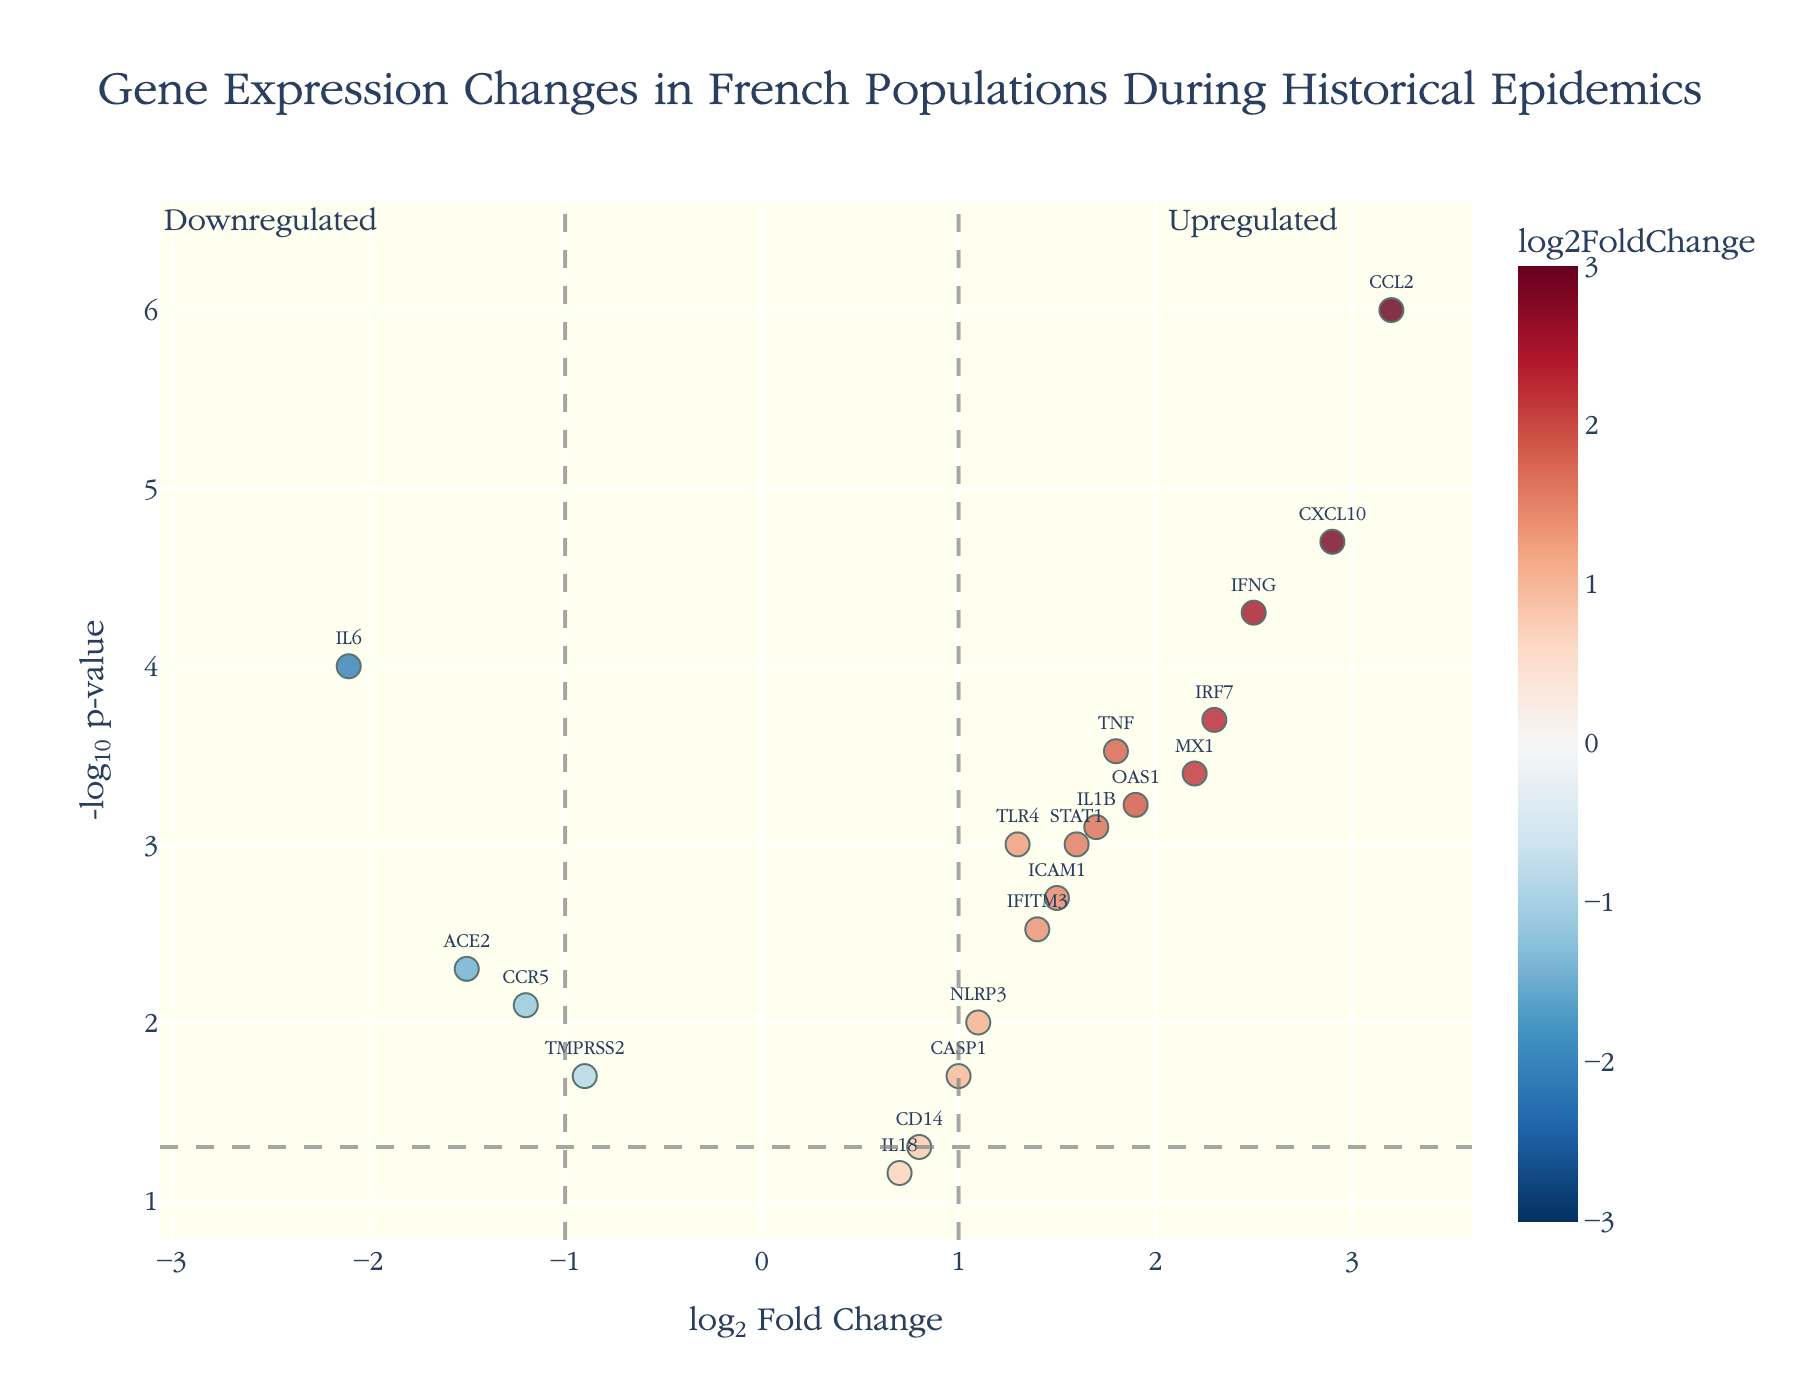what is the title of the plot? The title of the plot is located at the top center of the figure and provides a brief description of what the plot represents. By looking at the top of the figure, we can see that the title reads "Gene Expression Changes in French Populations During Historical Epidemics."
Answer: Gene Expression Changes in French Populations During Historical Epidemics Which gene has the highest -log10(p-value)? To determine the gene with the highest -log10(p-value), we look at the y-axis, which represents -log10(p-value), and identify the data point that reaches the highest position along this axis.
Answer: CCL2 Which genes are downregulated and have a p-value below 0.05? First, identify the genes with negative log2FoldChange values. Then check that their y-values, representing -log10(p-value), are above the horizontal threshold line (since higher -log10(p-value) indicates a lower p-value). The genes that meet these criteria are IL6, ACE2, and CCR5.
Answer: IL6, ACE2, CCR5 What color scale is used to indicate gene expression changes? The plot uses a color scale to represent different levels of log2FoldChange. The color scale mentioned in the description and evident from the figure is 'RdBu_r', which is typically a gradient from red to blue, indicating downregulation to upregulation.
Answer: Red to Blue Which genes are located in the significant upregulated region? The significant upregulated region is to the right of the vertical threshold line at log2FoldChange = 1 and above the horizontal threshold line at -log10(p-value) = 1.3 (corresponding to p-value < 0.05). The genes in this region are TNF, IFNG, TLR4, CCL2, CXCL10, MX1, OAS1, STAT1, and IRF7.
Answer: TNF, IFNG, TLR4, CCL2, CXCL10, MX1, OAS1, STAT1, IRF7 What is the x-axis title? The x-axis title is located at the bottom of the plot, explaining what is represented on the x-axis. By looking at the plot, we can see that the x-axis title reads "log2 Fold Change."
Answer: log2 Fold Change How many genes have a log2FoldChange greater than 2? To find this information, we look at the x-axis values and count the data points with log2FoldChange values greater than 2. The genes meeting this criterion are IFNG, CCL2, CXCL10, and IRF7.
Answer: 4 Compare the expression change of TNF and IFNG. Which one has a higher log2FoldChange value? To compare between TNF and IFNG, locate both genes on the x-axis and compare their positions. TNF is at 1.8, and IFNG is at 2.5, making IFNG's value higher.
Answer: IFNG What does the color of the gene markers represent? By referring to the color scale and its description, we understand that the color of the gene markers on the plot represents the log2FoldChange values, ranging from blue (downregulated) to red (upregulated).
Answer: log2FoldChange values 